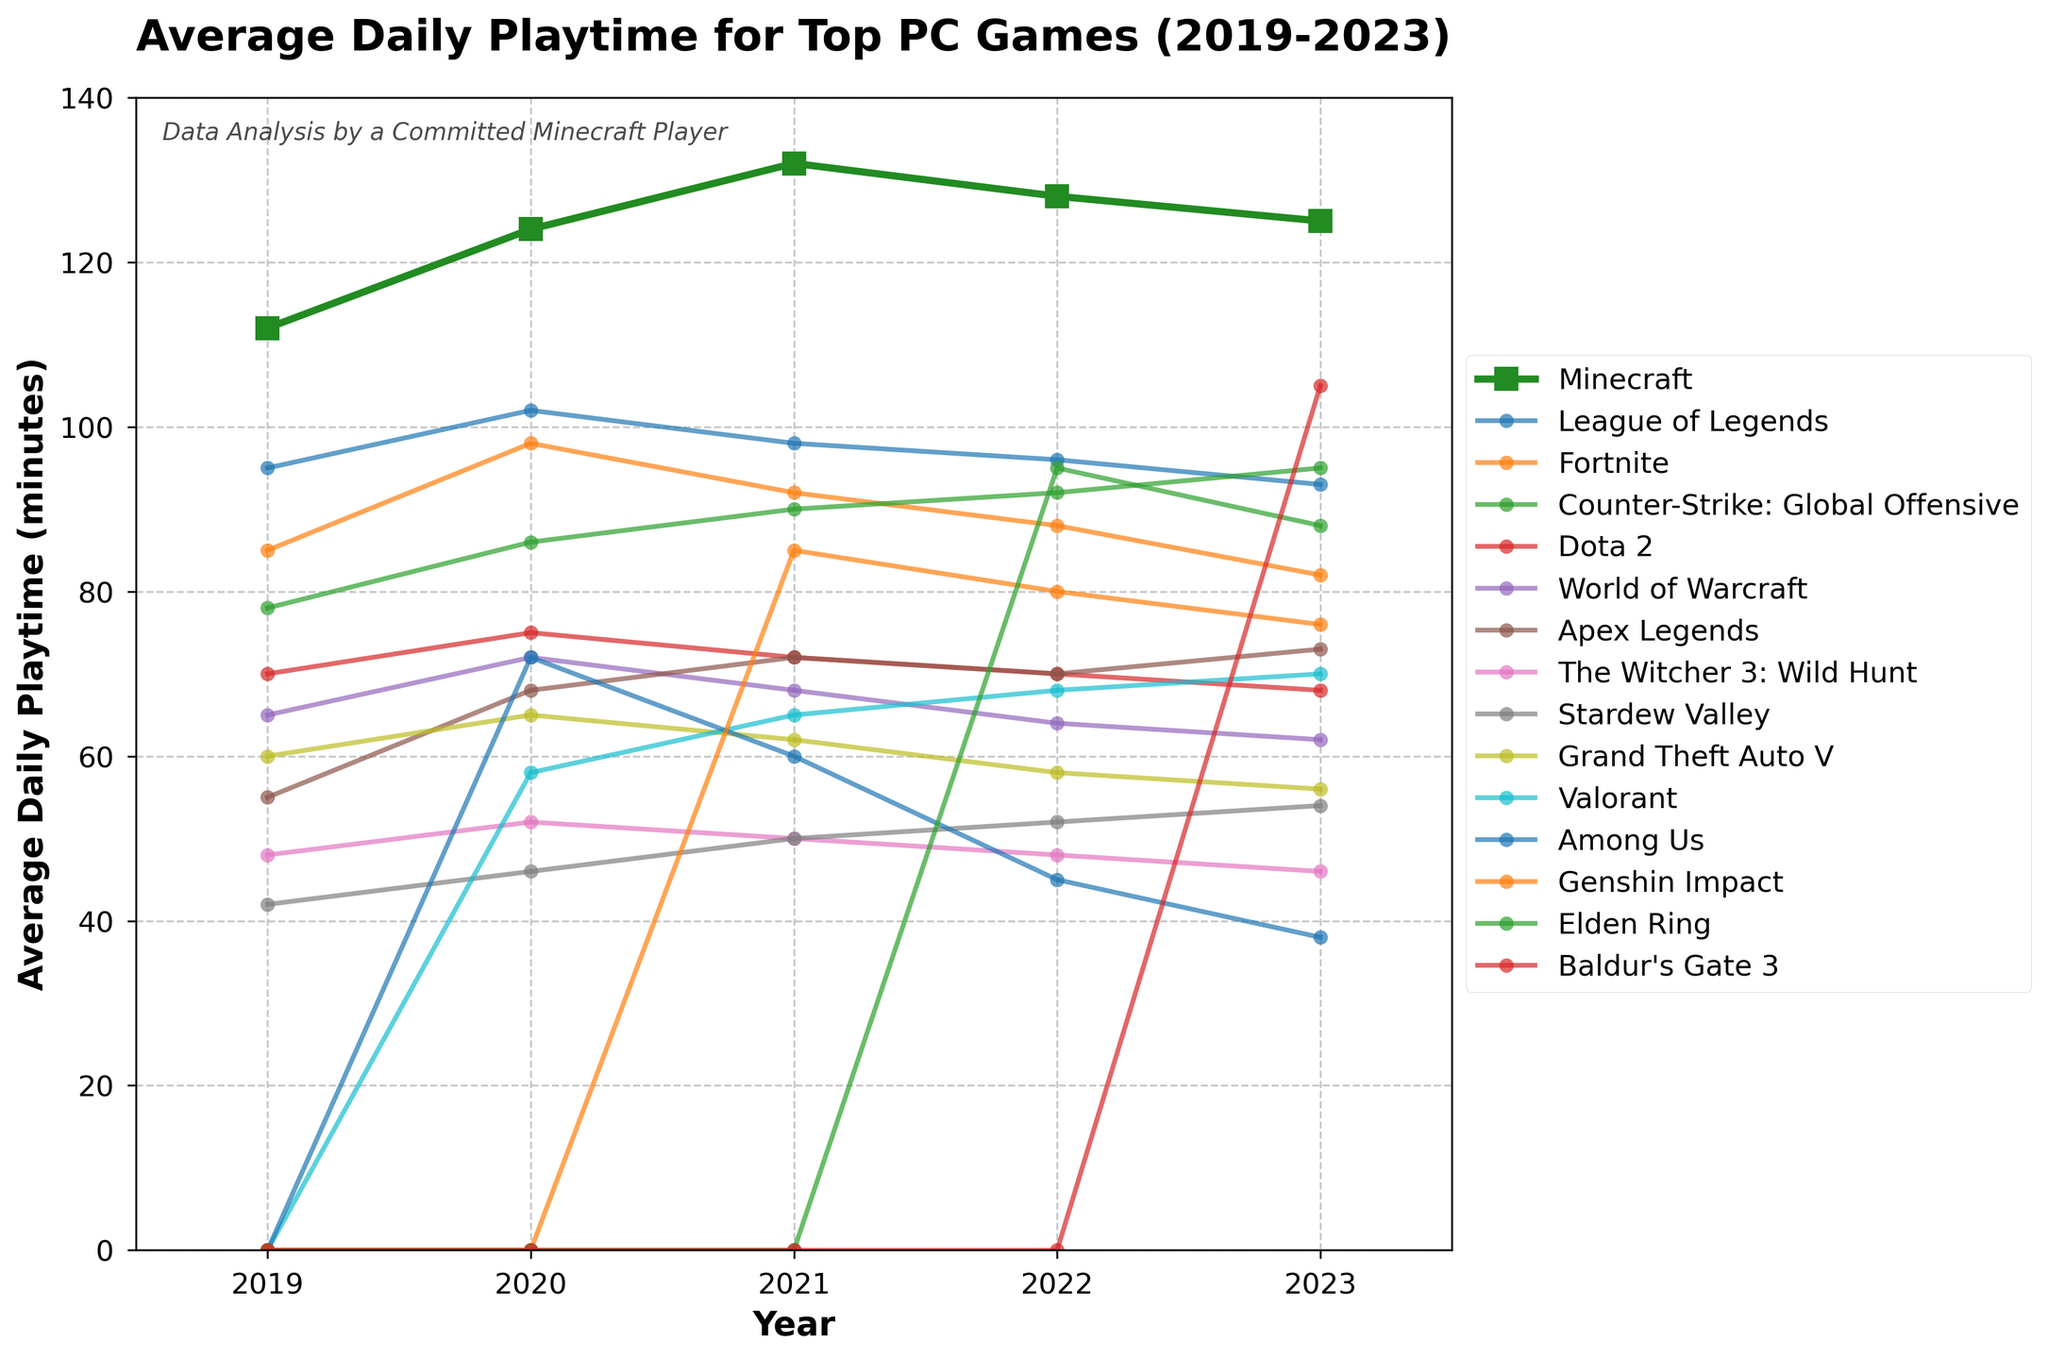What is the average daily playtime for Minecraft in 2021? The data shows that the average daily playtime for Minecraft in 2021 is marked clearly on the line chart.
Answer: 132 Which game had the highest average daily playtime in 2023, excluding Minecraft? By observing the highest point on the graph for the year 2023 and excluding Minecraft, Baldur's Gate 3 had the highest playtime.
Answer: Baldur's Gate 3 How did the playtime of Fortnite change from 2019 to 2023? We need to look at the values of Fortnite from 2019 to 2023 on the graph and note the changes. The playtime decreased from 85 in 2019 to 82 in 2023.
Answer: Decreased What is the difference in playtime between League of Legends and Counter-Strike: Global Offensive in 2023? By finding the playtime for both games in 2023 and subtracting one from the other (93 for League of Legends and 95 for Counter-Strike), the difference is calculated.
Answer: 2 Compare the trend in playtime for Minecraft and Valorant from 2020 to 2023. Which game shows a more significant trend change? Observing both lines from 2020 to 2023, Valorant shows a more significant upward trend compared to Minecraft's relatively stable trend.
Answer: Valorant What was the average daily playtime of Apex Legends in 2022 and 2023 combined? By adding the playtime for Apex Legends in 2022 (70) and 2023 (73) and then dividing by 2, we find the average (70 + 73) / 2 = 71.5.
Answer: 71.5 Which game saw the most dramatic increase in average playtime from 2019 to 2023? By observing the steepness of the lines, Valorant shows the most dramatic increase starting from 0 in 2019 to 70 in 2023.
Answer: Valorant What is the sum of average daily playtime in 2021 for Minecraft, League of Legends, and Fortnite? Summing the 2021 values for Minecraft (132), League of Legends (98), and Fortnite (92) gives us 132 + 98 + 92 = 322.
Answer: 322 Did the average playtime for Dota 2 increase or decrease from 2019 to 2023? By observing the trend for Dota 2, it shows a steady decrease from 70 in 2019 to 68 in 2023.
Answer: Decrease 